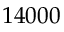<formula> <loc_0><loc_0><loc_500><loc_500>1 4 0 0 0</formula> 